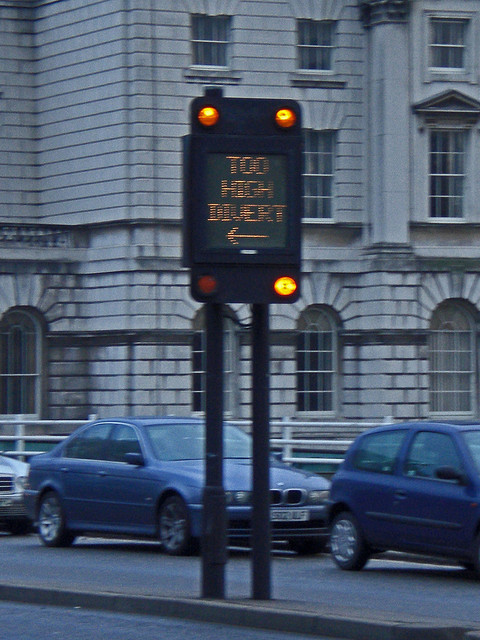<image>What does the sign say? I am not sure what the sign says. It could say 'too high divert', 'too high unknown', or 'too high invert'. What does the sign say? I don't know what the sign says. It could be "too high divert", "too high unknown", "too high divert left", "too high", or "too high invert". 